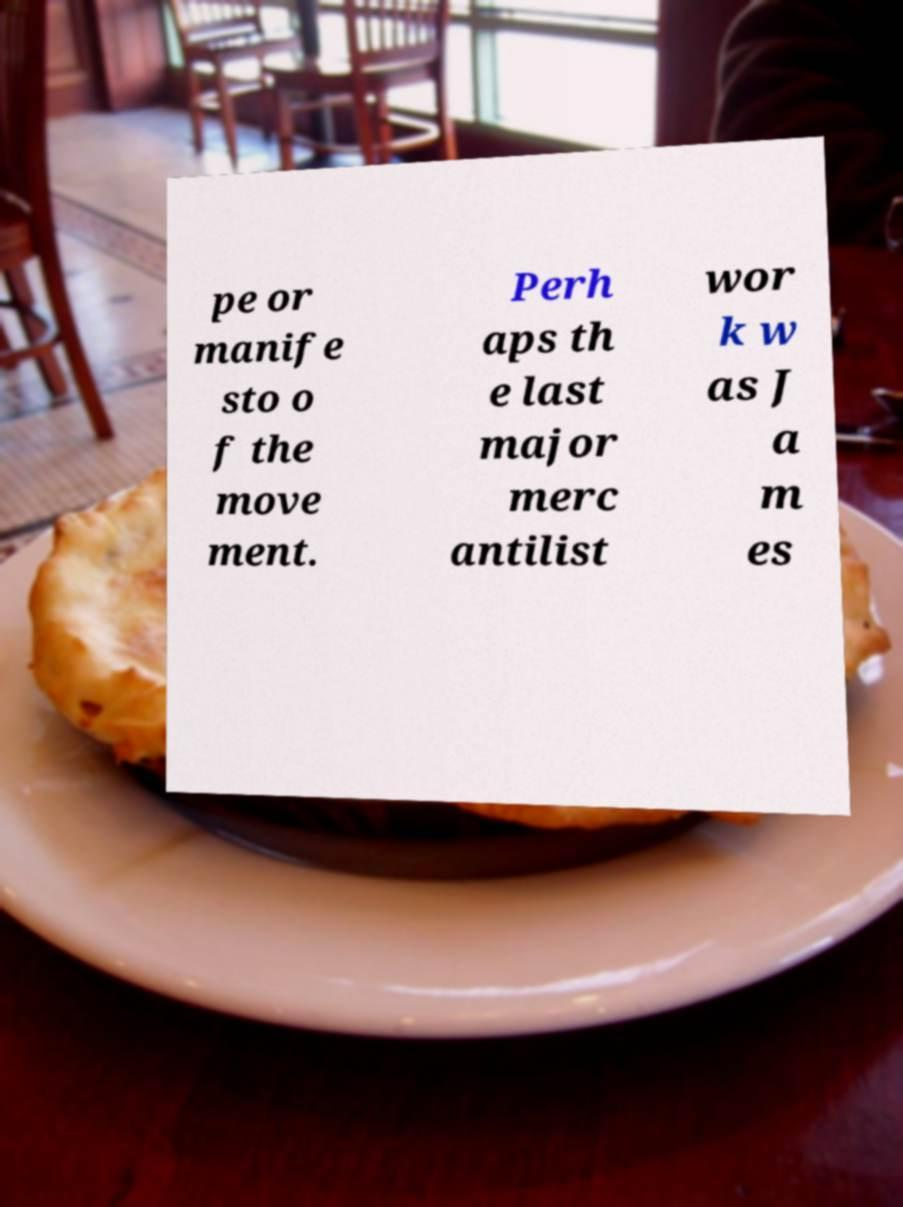For documentation purposes, I need the text within this image transcribed. Could you provide that? pe or manife sto o f the move ment. Perh aps th e last major merc antilist wor k w as J a m es 